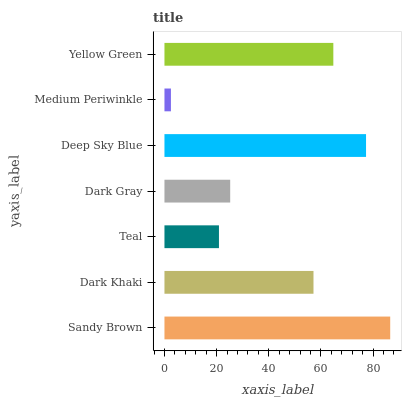Is Medium Periwinkle the minimum?
Answer yes or no. Yes. Is Sandy Brown the maximum?
Answer yes or no. Yes. Is Dark Khaki the minimum?
Answer yes or no. No. Is Dark Khaki the maximum?
Answer yes or no. No. Is Sandy Brown greater than Dark Khaki?
Answer yes or no. Yes. Is Dark Khaki less than Sandy Brown?
Answer yes or no. Yes. Is Dark Khaki greater than Sandy Brown?
Answer yes or no. No. Is Sandy Brown less than Dark Khaki?
Answer yes or no. No. Is Dark Khaki the high median?
Answer yes or no. Yes. Is Dark Khaki the low median?
Answer yes or no. Yes. Is Medium Periwinkle the high median?
Answer yes or no. No. Is Teal the low median?
Answer yes or no. No. 